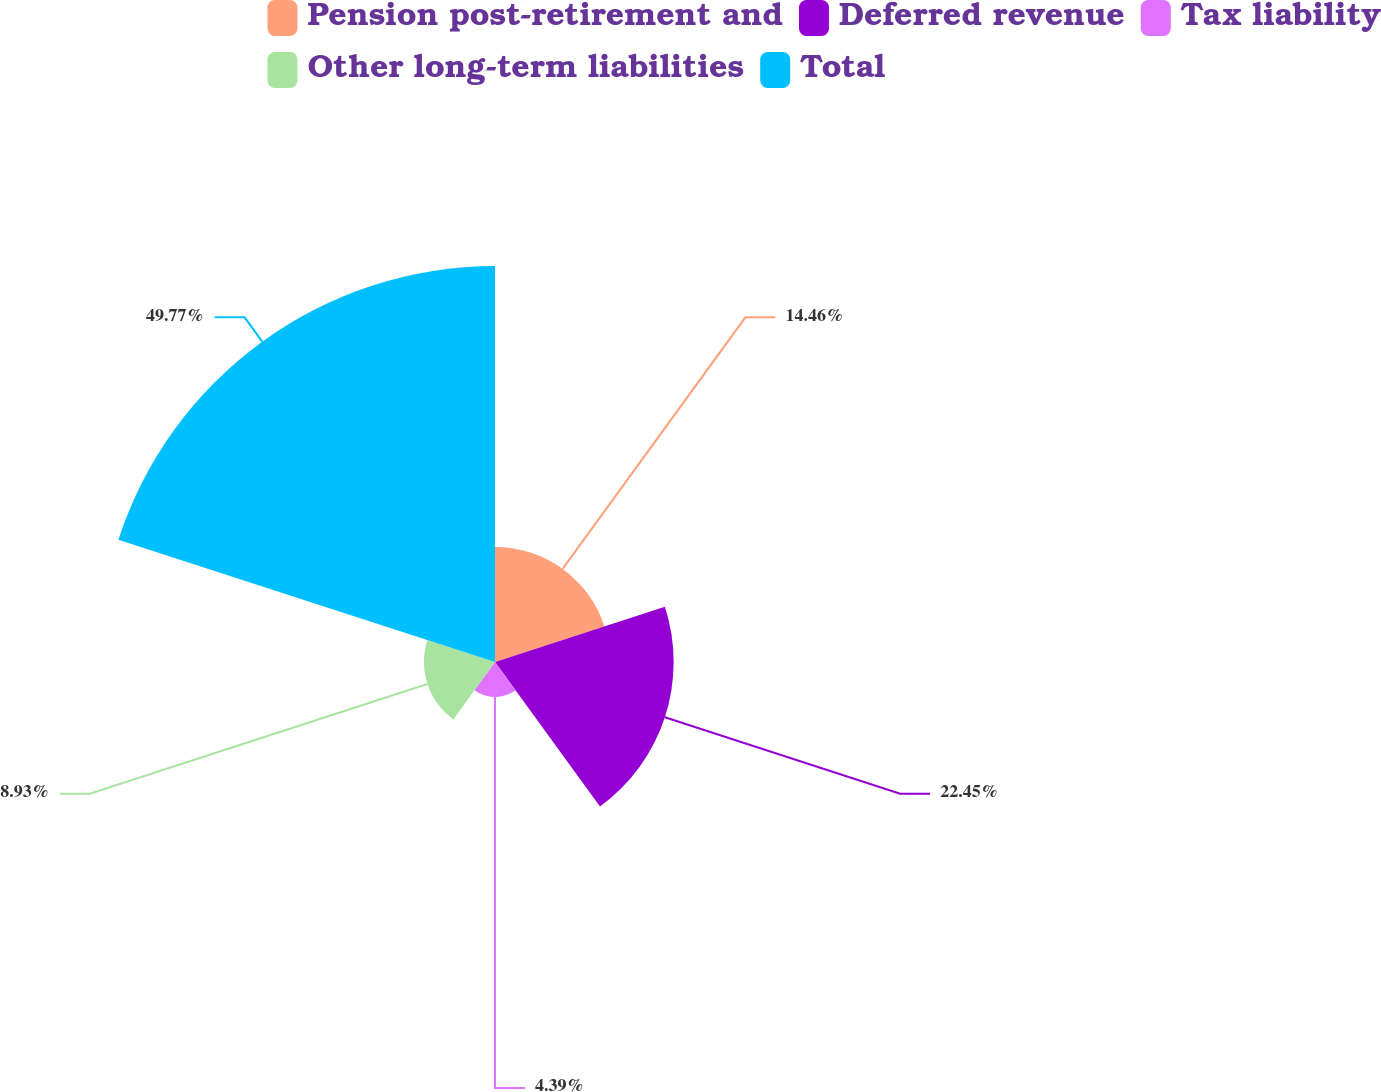Convert chart to OTSL. <chart><loc_0><loc_0><loc_500><loc_500><pie_chart><fcel>Pension post-retirement and<fcel>Deferred revenue<fcel>Tax liability<fcel>Other long-term liabilities<fcel>Total<nl><fcel>14.46%<fcel>22.45%<fcel>4.39%<fcel>8.93%<fcel>49.77%<nl></chart> 